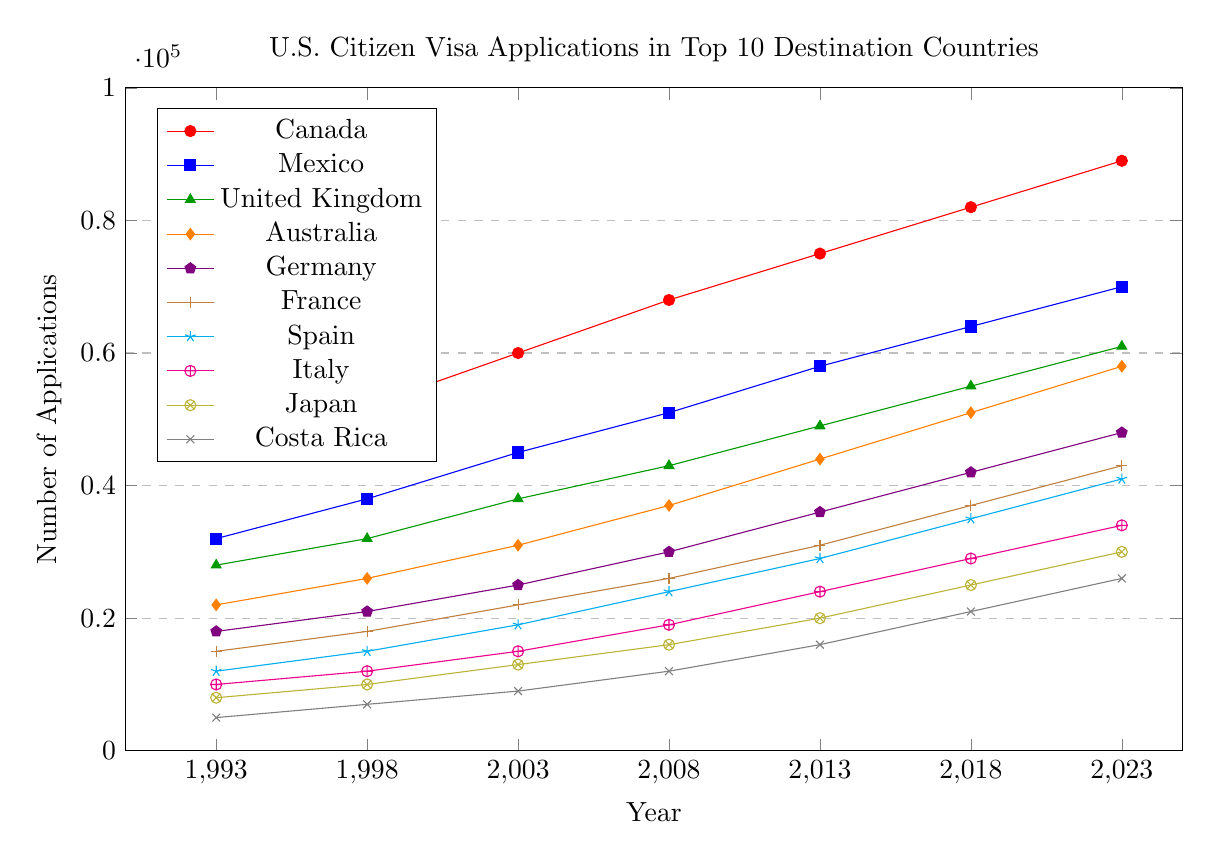Which country saw the highest number of visa applications in 2023? In the figure, each country's visa application trend is represented by a line of a different color. By looking at the plot for 2023, identify the highest point on the y-axis among the plotted countries.
Answer: Canada How many visa applications were submitted for Japan in 2013? Locate the line representing Japan (yellow with an otimes mark). Track this line to the point marked for the year 2013 and read the y-axis value.
Answer: 20,000 Which country had more visa applications in 2008: France or Spain? Find the lines representing France (brown with a + mark) and Spain (cyan with a star mark). Compare their y-axis values at the 2008 point.
Answer: Spain What is the total number of visa applications submitted in 1993 for Canada, Mexico, and the United Kingdom? Sum the 1993 y-axis values for Canada (45,000), Mexico (32,000), and the United Kingdom (28,000). 45,000 + 32,000 + 28,000 = 105,000.
Answer: 105,000 Between 1998 and 2003, which country had the largest increase in visa applications? Calculate the difference in visa applications for each country between 1998 and 2003 and identify the country with the largest positive change. Canada: 60,000 - 52,000 = 8,000, Mexico: 45,000 - 38,000 = 7,000, United Kingdom: 38,000 - 32,000 = 6,000, Australia: 31,000 - 26,000 = 5,000, Germany: 25,000 - 21,000 = 4,000, France: 22,000 - 18,000 = 4,000, Spain: 19,000 - 15,000 = 4,000, Italy: 15,000 - 12,000 = 3,000, Japan: 13,000 - 10,000 = 3,000, Costa Rica: 9,000 - 7,000 = 2,000.
Answer: Canada What is the average number of visa applications for Costa Rica from 1993 to 2023? Add the y-axis values for Costa Rica over the given years (5,000 + 7,000 + 9,000 + 12,000 + 16,000 + 21,000 + 26,000) and divide by the number of years (7). (5,000 + 7,000 + 9,000 + 12,000 + 16,000 + 21,000 + 26,000) / 7 = 13,714 (approx).
Answer: 13,714 Did more people apply for visas to Australia or Germany in 2023? Compare the y-axis values for Australia (orange with a diamond mark) and Germany (violet with a pentagon mark) in 2023.
Answer: Australia Which country saw the smallest number of visa applications throughout the entire period shown? Examine the lowest point on the y-axis for each country's line over all years.
Answer: Costa Rica What is the difference in visa applications between Canada and the United Kingdom in 2023? Subtract the y-axis value of the United Kingdom from Canada’s in 2023: 89,000 - 61,000 = 28,000.
Answer: 28,000 